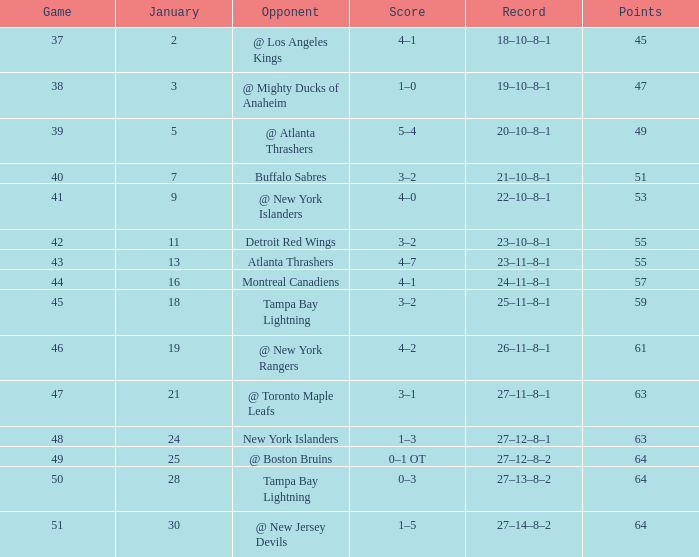How many Points have a January of 18? 1.0. 